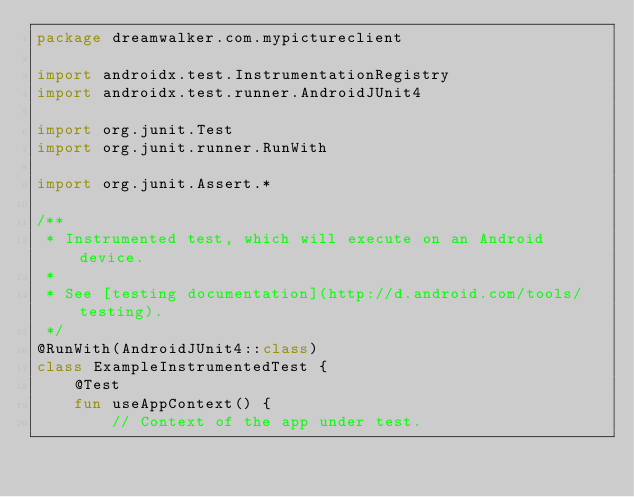<code> <loc_0><loc_0><loc_500><loc_500><_Kotlin_>package dreamwalker.com.mypictureclient

import androidx.test.InstrumentationRegistry
import androidx.test.runner.AndroidJUnit4

import org.junit.Test
import org.junit.runner.RunWith

import org.junit.Assert.*

/**
 * Instrumented test, which will execute on an Android device.
 *
 * See [testing documentation](http://d.android.com/tools/testing).
 */
@RunWith(AndroidJUnit4::class)
class ExampleInstrumentedTest {
    @Test
    fun useAppContext() {
        // Context of the app under test.</code> 